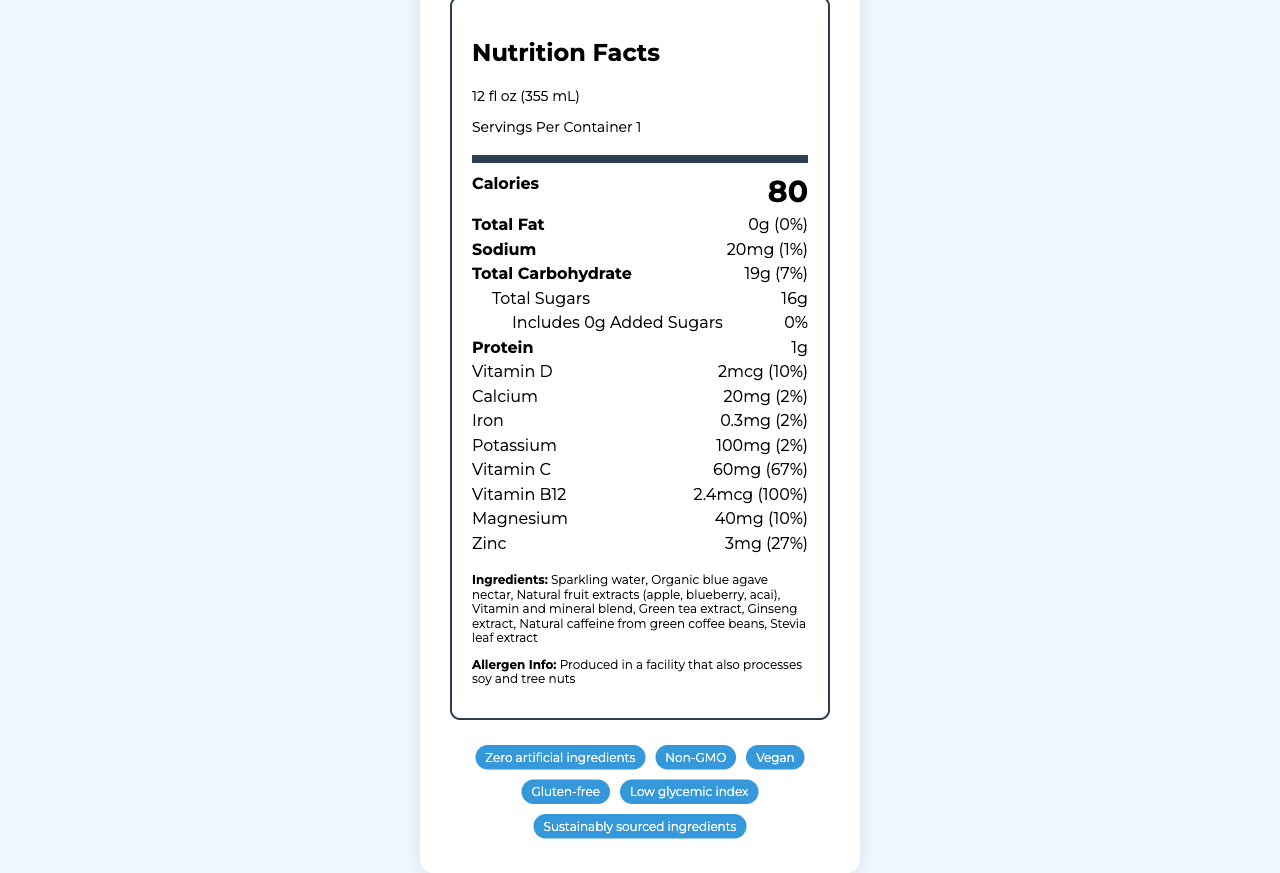who is the target audience for VitaBoost Energy Elixir? The document explicitly states that the target audience for VitaBoost Energy Elixir is health-conscious millennials seeking natural energy and wellness solutions.
Answer: Health-conscious millennials seeking natural energy and wellness solutions how many calories are in one serving of VitaBoost Energy Elixir? According to the nutrition facts, one serving of vitaBoost Energy Elixir contains 80 calories.
Answer: 80 calories what is the main ingredient in VitaBoost Energy Elixir? The first and therefore the main ingredient listed in VitaBoost Energy Elixir is sparkling water.
Answer: Sparkling water how much protein does one serving of VitaBoost Energy Elixir provide? The nutrition facts label states that there is 1g of protein per serving.
Answer: 1g what stores is VitaBoost Energy Elixir available in? The document lists the distribution channels as Whole Foods, Sprouts, Target, Amazon, and a direct-to-consumer website.
Answer: Whole Foods, Sprouts, Target, Amazon, Direct-to-consumer website Is VitaBoost Energy Elixir produced in a gluten-free environment? The document mentions that it is gluten-free but also states it is produced in a facility that processes soy and tree nuts. There is no specific claim regarding the product being produced in a gluten-free environment.
Answer: No how much vitamin c is in one serving of VitaBoost Energy Elixir? A. 30mg B. 45mg C. 60mg D. 75mg The Nutrition Facts label shows that one serving of VitaBoost Energy Elixir contains 60mg of Vitamin C.
Answer: C. 60mg how much iron is in one serving of VitaBoost Energy Elixir? A. 0.1mg B. 0.3mg C. 0.5mg D. 1mg According to the document, one serving of VitaBoost Energy Elixir contains 0.3mg of iron.
Answer: B. 0.3mg Does VitaBoost Energy Elixir contain any artificial ingredients? The marketing claims of the product state that it contains zero artificial ingredients.
Answer: No summarize the nutritional benefits of VitaBoost Energy Elixir. The summary of VitaBoost Energy Elixir includes its key functional benefits, nutritional content, and various health-related marketing claims, capturing its overall nutritional profile and appeal.
Answer: VitaBoost Energy Elixir offers natural energy boost, immune system support, cognitive function enhancement, and is rich in antioxidants. It provides 80 calories per serving and is low in sodium and sugars. It contains significant amounts of Vitamin C, Vitamin B12, Zinc, and is free from artificial ingredients, GMOs, gluten, and is vegan. how much caffeine is in one serving of VitaBoost Energy Elixir? The exact amount of caffeine is not listed in the document.
Answer: Not enough information how much total carbohydrate is in one serving of VitaBoost Energy Elixir? The nutrition facts label lists that there are 19g of total carbohydrates in one serving of VitaBoost Energy Elixir.
Answer: 19g how much vitamin B12 is in one serving of VitaBoost Energy Elixir? According to the nutrition facts, each serving of VitaBoost Energy Elixir contains 2.4mcg of Vitamin B12.
Answer: 2.4mcg is VitaBoost Energy Elixir vegan? The marketing claims include that VitaBoost Energy Elixir is vegan.
Answer: Yes 